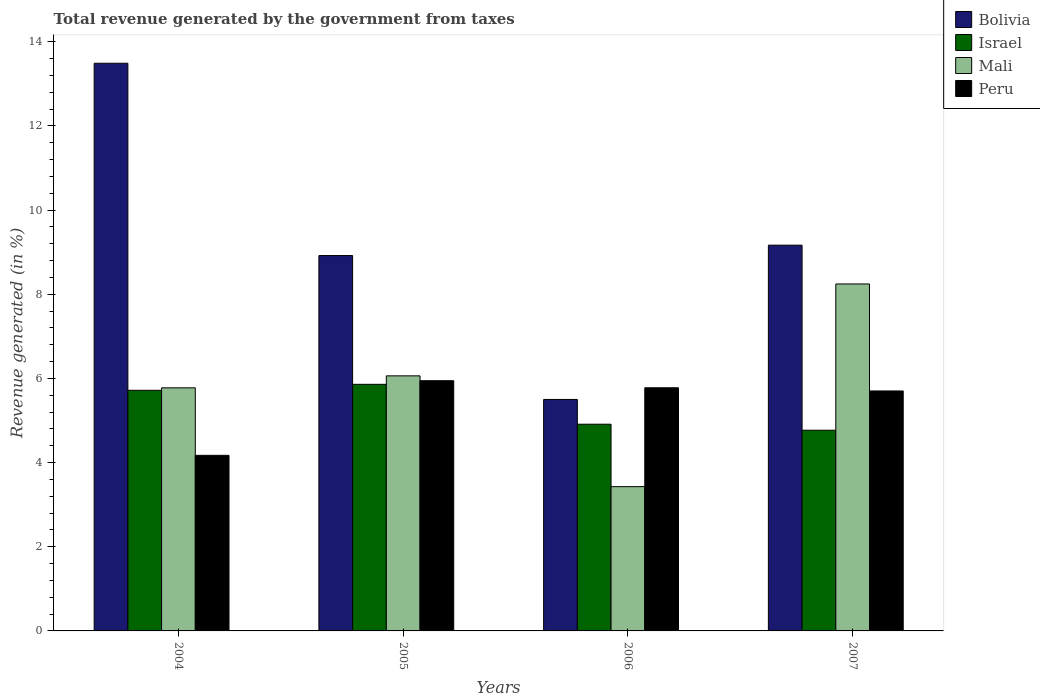How many bars are there on the 2nd tick from the left?
Your response must be concise. 4. What is the total revenue generated in Peru in 2005?
Keep it short and to the point. 5.95. Across all years, what is the maximum total revenue generated in Peru?
Make the answer very short. 5.95. Across all years, what is the minimum total revenue generated in Mali?
Offer a terse response. 3.43. In which year was the total revenue generated in Peru maximum?
Provide a succinct answer. 2005. In which year was the total revenue generated in Peru minimum?
Your answer should be compact. 2004. What is the total total revenue generated in Israel in the graph?
Ensure brevity in your answer.  21.26. What is the difference between the total revenue generated in Bolivia in 2004 and that in 2006?
Give a very brief answer. 7.99. What is the difference between the total revenue generated in Mali in 2005 and the total revenue generated in Israel in 2006?
Your answer should be very brief. 1.15. What is the average total revenue generated in Israel per year?
Your answer should be compact. 5.32. In the year 2004, what is the difference between the total revenue generated in Israel and total revenue generated in Mali?
Offer a very short reply. -0.06. In how many years, is the total revenue generated in Peru greater than 11.6 %?
Provide a short and direct response. 0. What is the ratio of the total revenue generated in Israel in 2005 to that in 2007?
Ensure brevity in your answer.  1.23. Is the total revenue generated in Peru in 2004 less than that in 2005?
Make the answer very short. Yes. What is the difference between the highest and the second highest total revenue generated in Mali?
Offer a terse response. 2.18. What is the difference between the highest and the lowest total revenue generated in Peru?
Give a very brief answer. 1.77. In how many years, is the total revenue generated in Peru greater than the average total revenue generated in Peru taken over all years?
Your answer should be very brief. 3. Is the sum of the total revenue generated in Israel in 2005 and 2007 greater than the maximum total revenue generated in Bolivia across all years?
Your answer should be compact. No. Is it the case that in every year, the sum of the total revenue generated in Peru and total revenue generated in Mali is greater than the sum of total revenue generated in Bolivia and total revenue generated in Israel?
Offer a terse response. No. What does the 4th bar from the left in 2004 represents?
Keep it short and to the point. Peru. What does the 4th bar from the right in 2007 represents?
Your response must be concise. Bolivia. Is it the case that in every year, the sum of the total revenue generated in Bolivia and total revenue generated in Mali is greater than the total revenue generated in Peru?
Give a very brief answer. Yes. How many bars are there?
Keep it short and to the point. 16. Are the values on the major ticks of Y-axis written in scientific E-notation?
Offer a very short reply. No. Does the graph contain any zero values?
Provide a short and direct response. No. Where does the legend appear in the graph?
Provide a short and direct response. Top right. How many legend labels are there?
Offer a very short reply. 4. What is the title of the graph?
Provide a succinct answer. Total revenue generated by the government from taxes. Does "Netherlands" appear as one of the legend labels in the graph?
Give a very brief answer. No. What is the label or title of the Y-axis?
Give a very brief answer. Revenue generated (in %). What is the Revenue generated (in %) of Bolivia in 2004?
Your answer should be very brief. 13.49. What is the Revenue generated (in %) in Israel in 2004?
Ensure brevity in your answer.  5.72. What is the Revenue generated (in %) of Mali in 2004?
Offer a terse response. 5.78. What is the Revenue generated (in %) of Peru in 2004?
Keep it short and to the point. 4.17. What is the Revenue generated (in %) in Bolivia in 2005?
Your answer should be very brief. 8.92. What is the Revenue generated (in %) in Israel in 2005?
Ensure brevity in your answer.  5.86. What is the Revenue generated (in %) of Mali in 2005?
Your answer should be very brief. 6.06. What is the Revenue generated (in %) in Peru in 2005?
Offer a terse response. 5.95. What is the Revenue generated (in %) of Bolivia in 2006?
Provide a short and direct response. 5.5. What is the Revenue generated (in %) in Israel in 2006?
Keep it short and to the point. 4.91. What is the Revenue generated (in %) in Mali in 2006?
Provide a short and direct response. 3.43. What is the Revenue generated (in %) in Peru in 2006?
Offer a very short reply. 5.78. What is the Revenue generated (in %) in Bolivia in 2007?
Ensure brevity in your answer.  9.17. What is the Revenue generated (in %) of Israel in 2007?
Offer a terse response. 4.77. What is the Revenue generated (in %) of Mali in 2007?
Keep it short and to the point. 8.25. What is the Revenue generated (in %) in Peru in 2007?
Provide a succinct answer. 5.7. Across all years, what is the maximum Revenue generated (in %) in Bolivia?
Your answer should be very brief. 13.49. Across all years, what is the maximum Revenue generated (in %) of Israel?
Give a very brief answer. 5.86. Across all years, what is the maximum Revenue generated (in %) of Mali?
Provide a succinct answer. 8.25. Across all years, what is the maximum Revenue generated (in %) in Peru?
Provide a succinct answer. 5.95. Across all years, what is the minimum Revenue generated (in %) of Bolivia?
Offer a very short reply. 5.5. Across all years, what is the minimum Revenue generated (in %) in Israel?
Provide a succinct answer. 4.77. Across all years, what is the minimum Revenue generated (in %) in Mali?
Your response must be concise. 3.43. Across all years, what is the minimum Revenue generated (in %) in Peru?
Your response must be concise. 4.17. What is the total Revenue generated (in %) of Bolivia in the graph?
Make the answer very short. 37.08. What is the total Revenue generated (in %) in Israel in the graph?
Provide a short and direct response. 21.26. What is the total Revenue generated (in %) in Mali in the graph?
Give a very brief answer. 23.51. What is the total Revenue generated (in %) in Peru in the graph?
Provide a short and direct response. 21.6. What is the difference between the Revenue generated (in %) in Bolivia in 2004 and that in 2005?
Your response must be concise. 4.57. What is the difference between the Revenue generated (in %) of Israel in 2004 and that in 2005?
Your answer should be compact. -0.14. What is the difference between the Revenue generated (in %) of Mali in 2004 and that in 2005?
Give a very brief answer. -0.28. What is the difference between the Revenue generated (in %) in Peru in 2004 and that in 2005?
Offer a terse response. -1.77. What is the difference between the Revenue generated (in %) in Bolivia in 2004 and that in 2006?
Your answer should be compact. 7.99. What is the difference between the Revenue generated (in %) of Israel in 2004 and that in 2006?
Give a very brief answer. 0.81. What is the difference between the Revenue generated (in %) of Mali in 2004 and that in 2006?
Make the answer very short. 2.35. What is the difference between the Revenue generated (in %) of Peru in 2004 and that in 2006?
Provide a short and direct response. -1.61. What is the difference between the Revenue generated (in %) of Bolivia in 2004 and that in 2007?
Your response must be concise. 4.32. What is the difference between the Revenue generated (in %) in Israel in 2004 and that in 2007?
Keep it short and to the point. 0.95. What is the difference between the Revenue generated (in %) in Mali in 2004 and that in 2007?
Your answer should be compact. -2.47. What is the difference between the Revenue generated (in %) in Peru in 2004 and that in 2007?
Offer a terse response. -1.53. What is the difference between the Revenue generated (in %) in Bolivia in 2005 and that in 2006?
Make the answer very short. 3.42. What is the difference between the Revenue generated (in %) of Israel in 2005 and that in 2006?
Make the answer very short. 0.95. What is the difference between the Revenue generated (in %) of Mali in 2005 and that in 2006?
Your answer should be very brief. 2.63. What is the difference between the Revenue generated (in %) in Peru in 2005 and that in 2006?
Offer a very short reply. 0.17. What is the difference between the Revenue generated (in %) in Bolivia in 2005 and that in 2007?
Offer a terse response. -0.25. What is the difference between the Revenue generated (in %) of Israel in 2005 and that in 2007?
Make the answer very short. 1.09. What is the difference between the Revenue generated (in %) in Mali in 2005 and that in 2007?
Ensure brevity in your answer.  -2.18. What is the difference between the Revenue generated (in %) of Peru in 2005 and that in 2007?
Offer a terse response. 0.24. What is the difference between the Revenue generated (in %) of Bolivia in 2006 and that in 2007?
Give a very brief answer. -3.67. What is the difference between the Revenue generated (in %) of Israel in 2006 and that in 2007?
Provide a short and direct response. 0.14. What is the difference between the Revenue generated (in %) of Mali in 2006 and that in 2007?
Give a very brief answer. -4.82. What is the difference between the Revenue generated (in %) in Peru in 2006 and that in 2007?
Your answer should be very brief. 0.08. What is the difference between the Revenue generated (in %) in Bolivia in 2004 and the Revenue generated (in %) in Israel in 2005?
Give a very brief answer. 7.63. What is the difference between the Revenue generated (in %) of Bolivia in 2004 and the Revenue generated (in %) of Mali in 2005?
Make the answer very short. 7.43. What is the difference between the Revenue generated (in %) in Bolivia in 2004 and the Revenue generated (in %) in Peru in 2005?
Your answer should be very brief. 7.54. What is the difference between the Revenue generated (in %) in Israel in 2004 and the Revenue generated (in %) in Mali in 2005?
Offer a very short reply. -0.34. What is the difference between the Revenue generated (in %) of Israel in 2004 and the Revenue generated (in %) of Peru in 2005?
Make the answer very short. -0.23. What is the difference between the Revenue generated (in %) of Mali in 2004 and the Revenue generated (in %) of Peru in 2005?
Your answer should be compact. -0.17. What is the difference between the Revenue generated (in %) of Bolivia in 2004 and the Revenue generated (in %) of Israel in 2006?
Give a very brief answer. 8.58. What is the difference between the Revenue generated (in %) in Bolivia in 2004 and the Revenue generated (in %) in Mali in 2006?
Offer a terse response. 10.06. What is the difference between the Revenue generated (in %) of Bolivia in 2004 and the Revenue generated (in %) of Peru in 2006?
Make the answer very short. 7.71. What is the difference between the Revenue generated (in %) of Israel in 2004 and the Revenue generated (in %) of Mali in 2006?
Keep it short and to the point. 2.29. What is the difference between the Revenue generated (in %) of Israel in 2004 and the Revenue generated (in %) of Peru in 2006?
Your answer should be very brief. -0.06. What is the difference between the Revenue generated (in %) in Mali in 2004 and the Revenue generated (in %) in Peru in 2006?
Offer a terse response. -0. What is the difference between the Revenue generated (in %) in Bolivia in 2004 and the Revenue generated (in %) in Israel in 2007?
Make the answer very short. 8.72. What is the difference between the Revenue generated (in %) in Bolivia in 2004 and the Revenue generated (in %) in Mali in 2007?
Your answer should be compact. 5.25. What is the difference between the Revenue generated (in %) in Bolivia in 2004 and the Revenue generated (in %) in Peru in 2007?
Make the answer very short. 7.79. What is the difference between the Revenue generated (in %) in Israel in 2004 and the Revenue generated (in %) in Mali in 2007?
Your response must be concise. -2.53. What is the difference between the Revenue generated (in %) in Israel in 2004 and the Revenue generated (in %) in Peru in 2007?
Offer a very short reply. 0.02. What is the difference between the Revenue generated (in %) of Mali in 2004 and the Revenue generated (in %) of Peru in 2007?
Your response must be concise. 0.07. What is the difference between the Revenue generated (in %) of Bolivia in 2005 and the Revenue generated (in %) of Israel in 2006?
Provide a short and direct response. 4.01. What is the difference between the Revenue generated (in %) of Bolivia in 2005 and the Revenue generated (in %) of Mali in 2006?
Your response must be concise. 5.49. What is the difference between the Revenue generated (in %) of Bolivia in 2005 and the Revenue generated (in %) of Peru in 2006?
Your answer should be very brief. 3.14. What is the difference between the Revenue generated (in %) of Israel in 2005 and the Revenue generated (in %) of Mali in 2006?
Offer a very short reply. 2.43. What is the difference between the Revenue generated (in %) of Israel in 2005 and the Revenue generated (in %) of Peru in 2006?
Your answer should be compact. 0.08. What is the difference between the Revenue generated (in %) of Mali in 2005 and the Revenue generated (in %) of Peru in 2006?
Give a very brief answer. 0.28. What is the difference between the Revenue generated (in %) of Bolivia in 2005 and the Revenue generated (in %) of Israel in 2007?
Give a very brief answer. 4.15. What is the difference between the Revenue generated (in %) in Bolivia in 2005 and the Revenue generated (in %) in Mali in 2007?
Provide a short and direct response. 0.68. What is the difference between the Revenue generated (in %) of Bolivia in 2005 and the Revenue generated (in %) of Peru in 2007?
Your answer should be compact. 3.22. What is the difference between the Revenue generated (in %) in Israel in 2005 and the Revenue generated (in %) in Mali in 2007?
Provide a short and direct response. -2.39. What is the difference between the Revenue generated (in %) in Israel in 2005 and the Revenue generated (in %) in Peru in 2007?
Offer a terse response. 0.16. What is the difference between the Revenue generated (in %) of Mali in 2005 and the Revenue generated (in %) of Peru in 2007?
Provide a succinct answer. 0.36. What is the difference between the Revenue generated (in %) in Bolivia in 2006 and the Revenue generated (in %) in Israel in 2007?
Offer a very short reply. 0.73. What is the difference between the Revenue generated (in %) of Bolivia in 2006 and the Revenue generated (in %) of Mali in 2007?
Ensure brevity in your answer.  -2.74. What is the difference between the Revenue generated (in %) of Bolivia in 2006 and the Revenue generated (in %) of Peru in 2007?
Give a very brief answer. -0.2. What is the difference between the Revenue generated (in %) in Israel in 2006 and the Revenue generated (in %) in Mali in 2007?
Offer a terse response. -3.33. What is the difference between the Revenue generated (in %) of Israel in 2006 and the Revenue generated (in %) of Peru in 2007?
Keep it short and to the point. -0.79. What is the difference between the Revenue generated (in %) of Mali in 2006 and the Revenue generated (in %) of Peru in 2007?
Your response must be concise. -2.27. What is the average Revenue generated (in %) in Bolivia per year?
Keep it short and to the point. 9.27. What is the average Revenue generated (in %) in Israel per year?
Your answer should be very brief. 5.32. What is the average Revenue generated (in %) in Mali per year?
Offer a terse response. 5.88. What is the average Revenue generated (in %) in Peru per year?
Make the answer very short. 5.4. In the year 2004, what is the difference between the Revenue generated (in %) in Bolivia and Revenue generated (in %) in Israel?
Your response must be concise. 7.77. In the year 2004, what is the difference between the Revenue generated (in %) of Bolivia and Revenue generated (in %) of Mali?
Provide a succinct answer. 7.71. In the year 2004, what is the difference between the Revenue generated (in %) of Bolivia and Revenue generated (in %) of Peru?
Provide a succinct answer. 9.32. In the year 2004, what is the difference between the Revenue generated (in %) in Israel and Revenue generated (in %) in Mali?
Your response must be concise. -0.06. In the year 2004, what is the difference between the Revenue generated (in %) in Israel and Revenue generated (in %) in Peru?
Provide a short and direct response. 1.55. In the year 2004, what is the difference between the Revenue generated (in %) in Mali and Revenue generated (in %) in Peru?
Make the answer very short. 1.6. In the year 2005, what is the difference between the Revenue generated (in %) in Bolivia and Revenue generated (in %) in Israel?
Your answer should be very brief. 3.06. In the year 2005, what is the difference between the Revenue generated (in %) of Bolivia and Revenue generated (in %) of Mali?
Your answer should be compact. 2.86. In the year 2005, what is the difference between the Revenue generated (in %) in Bolivia and Revenue generated (in %) in Peru?
Provide a short and direct response. 2.97. In the year 2005, what is the difference between the Revenue generated (in %) in Israel and Revenue generated (in %) in Mali?
Offer a very short reply. -0.2. In the year 2005, what is the difference between the Revenue generated (in %) in Israel and Revenue generated (in %) in Peru?
Give a very brief answer. -0.09. In the year 2005, what is the difference between the Revenue generated (in %) in Mali and Revenue generated (in %) in Peru?
Your answer should be very brief. 0.12. In the year 2006, what is the difference between the Revenue generated (in %) of Bolivia and Revenue generated (in %) of Israel?
Ensure brevity in your answer.  0.59. In the year 2006, what is the difference between the Revenue generated (in %) in Bolivia and Revenue generated (in %) in Mali?
Provide a succinct answer. 2.07. In the year 2006, what is the difference between the Revenue generated (in %) of Bolivia and Revenue generated (in %) of Peru?
Your answer should be very brief. -0.28. In the year 2006, what is the difference between the Revenue generated (in %) of Israel and Revenue generated (in %) of Mali?
Make the answer very short. 1.48. In the year 2006, what is the difference between the Revenue generated (in %) in Israel and Revenue generated (in %) in Peru?
Give a very brief answer. -0.87. In the year 2006, what is the difference between the Revenue generated (in %) of Mali and Revenue generated (in %) of Peru?
Offer a terse response. -2.35. In the year 2007, what is the difference between the Revenue generated (in %) in Bolivia and Revenue generated (in %) in Israel?
Your answer should be compact. 4.4. In the year 2007, what is the difference between the Revenue generated (in %) of Bolivia and Revenue generated (in %) of Mali?
Give a very brief answer. 0.92. In the year 2007, what is the difference between the Revenue generated (in %) in Bolivia and Revenue generated (in %) in Peru?
Provide a short and direct response. 3.46. In the year 2007, what is the difference between the Revenue generated (in %) of Israel and Revenue generated (in %) of Mali?
Offer a terse response. -3.48. In the year 2007, what is the difference between the Revenue generated (in %) in Israel and Revenue generated (in %) in Peru?
Your response must be concise. -0.93. In the year 2007, what is the difference between the Revenue generated (in %) of Mali and Revenue generated (in %) of Peru?
Offer a very short reply. 2.54. What is the ratio of the Revenue generated (in %) in Bolivia in 2004 to that in 2005?
Ensure brevity in your answer.  1.51. What is the ratio of the Revenue generated (in %) in Israel in 2004 to that in 2005?
Provide a short and direct response. 0.98. What is the ratio of the Revenue generated (in %) of Mali in 2004 to that in 2005?
Ensure brevity in your answer.  0.95. What is the ratio of the Revenue generated (in %) in Peru in 2004 to that in 2005?
Your answer should be very brief. 0.7. What is the ratio of the Revenue generated (in %) in Bolivia in 2004 to that in 2006?
Offer a very short reply. 2.45. What is the ratio of the Revenue generated (in %) in Israel in 2004 to that in 2006?
Keep it short and to the point. 1.16. What is the ratio of the Revenue generated (in %) in Mali in 2004 to that in 2006?
Provide a succinct answer. 1.69. What is the ratio of the Revenue generated (in %) in Peru in 2004 to that in 2006?
Make the answer very short. 0.72. What is the ratio of the Revenue generated (in %) in Bolivia in 2004 to that in 2007?
Give a very brief answer. 1.47. What is the ratio of the Revenue generated (in %) of Israel in 2004 to that in 2007?
Your answer should be compact. 1.2. What is the ratio of the Revenue generated (in %) of Mali in 2004 to that in 2007?
Make the answer very short. 0.7. What is the ratio of the Revenue generated (in %) of Peru in 2004 to that in 2007?
Offer a terse response. 0.73. What is the ratio of the Revenue generated (in %) of Bolivia in 2005 to that in 2006?
Your response must be concise. 1.62. What is the ratio of the Revenue generated (in %) in Israel in 2005 to that in 2006?
Your answer should be very brief. 1.19. What is the ratio of the Revenue generated (in %) of Mali in 2005 to that in 2006?
Keep it short and to the point. 1.77. What is the ratio of the Revenue generated (in %) of Peru in 2005 to that in 2006?
Offer a very short reply. 1.03. What is the ratio of the Revenue generated (in %) in Bolivia in 2005 to that in 2007?
Offer a very short reply. 0.97. What is the ratio of the Revenue generated (in %) in Israel in 2005 to that in 2007?
Provide a short and direct response. 1.23. What is the ratio of the Revenue generated (in %) in Mali in 2005 to that in 2007?
Give a very brief answer. 0.74. What is the ratio of the Revenue generated (in %) in Peru in 2005 to that in 2007?
Provide a succinct answer. 1.04. What is the ratio of the Revenue generated (in %) in Bolivia in 2006 to that in 2007?
Provide a short and direct response. 0.6. What is the ratio of the Revenue generated (in %) of Israel in 2006 to that in 2007?
Your answer should be very brief. 1.03. What is the ratio of the Revenue generated (in %) in Mali in 2006 to that in 2007?
Make the answer very short. 0.42. What is the ratio of the Revenue generated (in %) in Peru in 2006 to that in 2007?
Give a very brief answer. 1.01. What is the difference between the highest and the second highest Revenue generated (in %) in Bolivia?
Offer a terse response. 4.32. What is the difference between the highest and the second highest Revenue generated (in %) in Israel?
Give a very brief answer. 0.14. What is the difference between the highest and the second highest Revenue generated (in %) in Mali?
Your answer should be compact. 2.18. What is the difference between the highest and the second highest Revenue generated (in %) of Peru?
Ensure brevity in your answer.  0.17. What is the difference between the highest and the lowest Revenue generated (in %) of Bolivia?
Give a very brief answer. 7.99. What is the difference between the highest and the lowest Revenue generated (in %) of Israel?
Offer a very short reply. 1.09. What is the difference between the highest and the lowest Revenue generated (in %) in Mali?
Ensure brevity in your answer.  4.82. What is the difference between the highest and the lowest Revenue generated (in %) of Peru?
Make the answer very short. 1.77. 